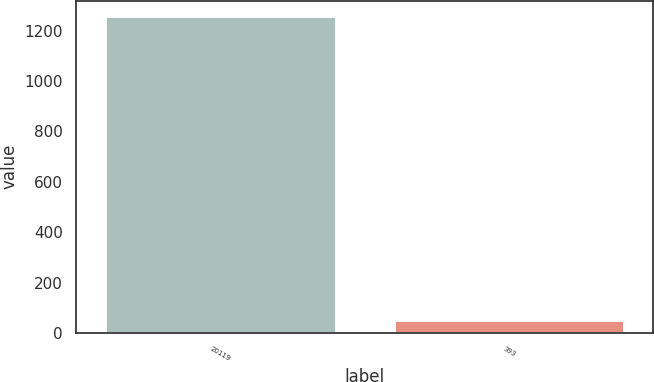<chart> <loc_0><loc_0><loc_500><loc_500><bar_chart><fcel>20119<fcel>393<nl><fcel>1256.9<fcel>50.4<nl></chart> 